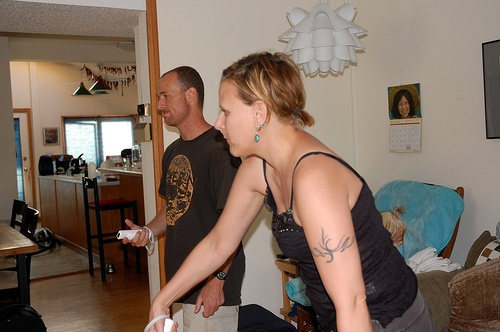Describe the objects in this image and their specific colors. I can see people in gray, tan, black, and salmon tones, people in gray, black, brown, and darkgray tones, chair in gray and teal tones, chair in gray, black, and maroon tones, and couch in gray, maroon, and black tones in this image. 